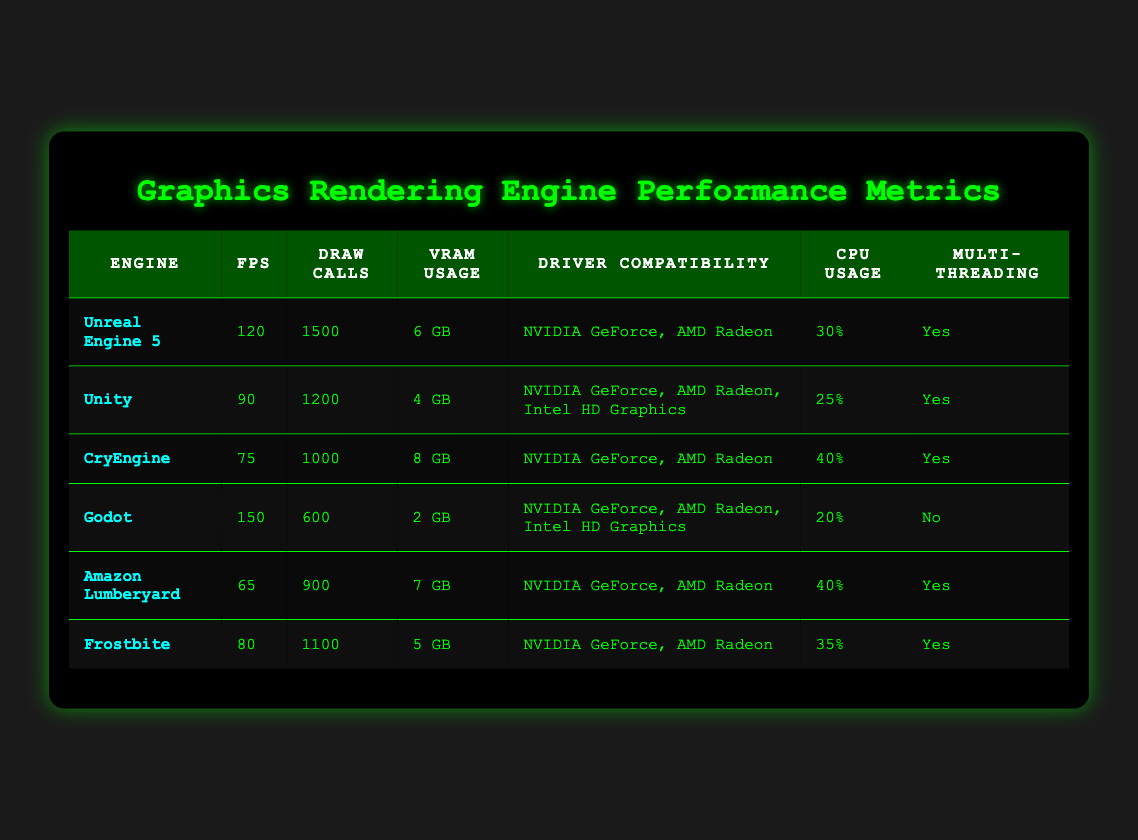What is the highest FPS recorded among the graphics engines? The highest FPS is 150, which is achieved by Godot.
Answer: 150 Which engine has the lowest VRAM usage? The engine with the lowest VRAM usage is Godot, using only 2 GB.
Answer: 2 GB How many draw calls does Unreal Engine 5 require? Unreal Engine 5 requires 1500 draw calls.
Answer: 1500 Which engines support multi-threading? Unreal Engine 5, Unity, CryEngine, Amazon Lumberyard, and Frostbite support multi-threading. Godot does not.
Answer: 5 What is the average CPU usage among the engines listed? To calculate the average CPU usage, sum the values: 30% + 25% + 40% + 20% + 40% + 35% = 190%, and then divide by 6 (the number of engines): 190% / 6 = 31.67%.
Answer: 31.67% Which engine has the highest VRAM usage? CryEngine uses the highest amount of VRAM at 8 GB.
Answer: 8 GB Is Unity compatible with Intel HD Graphics? Yes, Unity is compatible with Intel HD Graphics along with NVIDIA GeForce and AMD Radeon.
Answer: Yes Which engine has the most draw calls? Unreal Engine 5 has the most draw calls at 1500.
Answer: 1500 What percentage of CPU does Amazon Lumberyard use? Amazon Lumberyard uses 40% of the CPU.
Answer: 40% Which engine combination provides the best performance based on FPS? Comparing the FPS values, Godot (150) has the best performance followed by Unreal Engine 5 (120) and Unity (90). Therefore, Godot is the top performer.
Answer: Godot What is the difference in draw calls between the engine with the highest and the lowest draw calls? The engine with the highest draw calls is Unreal Engine 5 (1500 draw calls) and the lowest is Godot (600 draw calls). The difference is 1500 - 600 = 900.
Answer: 900 